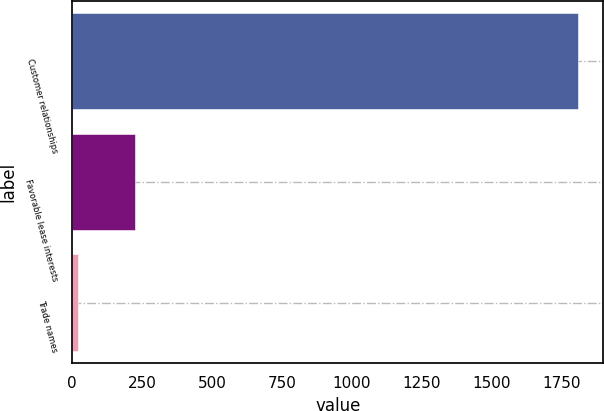<chart> <loc_0><loc_0><loc_500><loc_500><bar_chart><fcel>Customer relationships<fcel>Favorable lease interests<fcel>Trade names<nl><fcel>1810<fcel>224<fcel>20<nl></chart> 